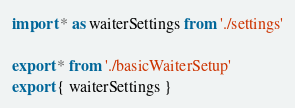<code> <loc_0><loc_0><loc_500><loc_500><_JavaScript_>import * as waiterSettings from './settings'

export * from './basicWaiterSetup'
export { waiterSettings }
</code> 